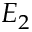Convert formula to latex. <formula><loc_0><loc_0><loc_500><loc_500>E _ { 2 }</formula> 